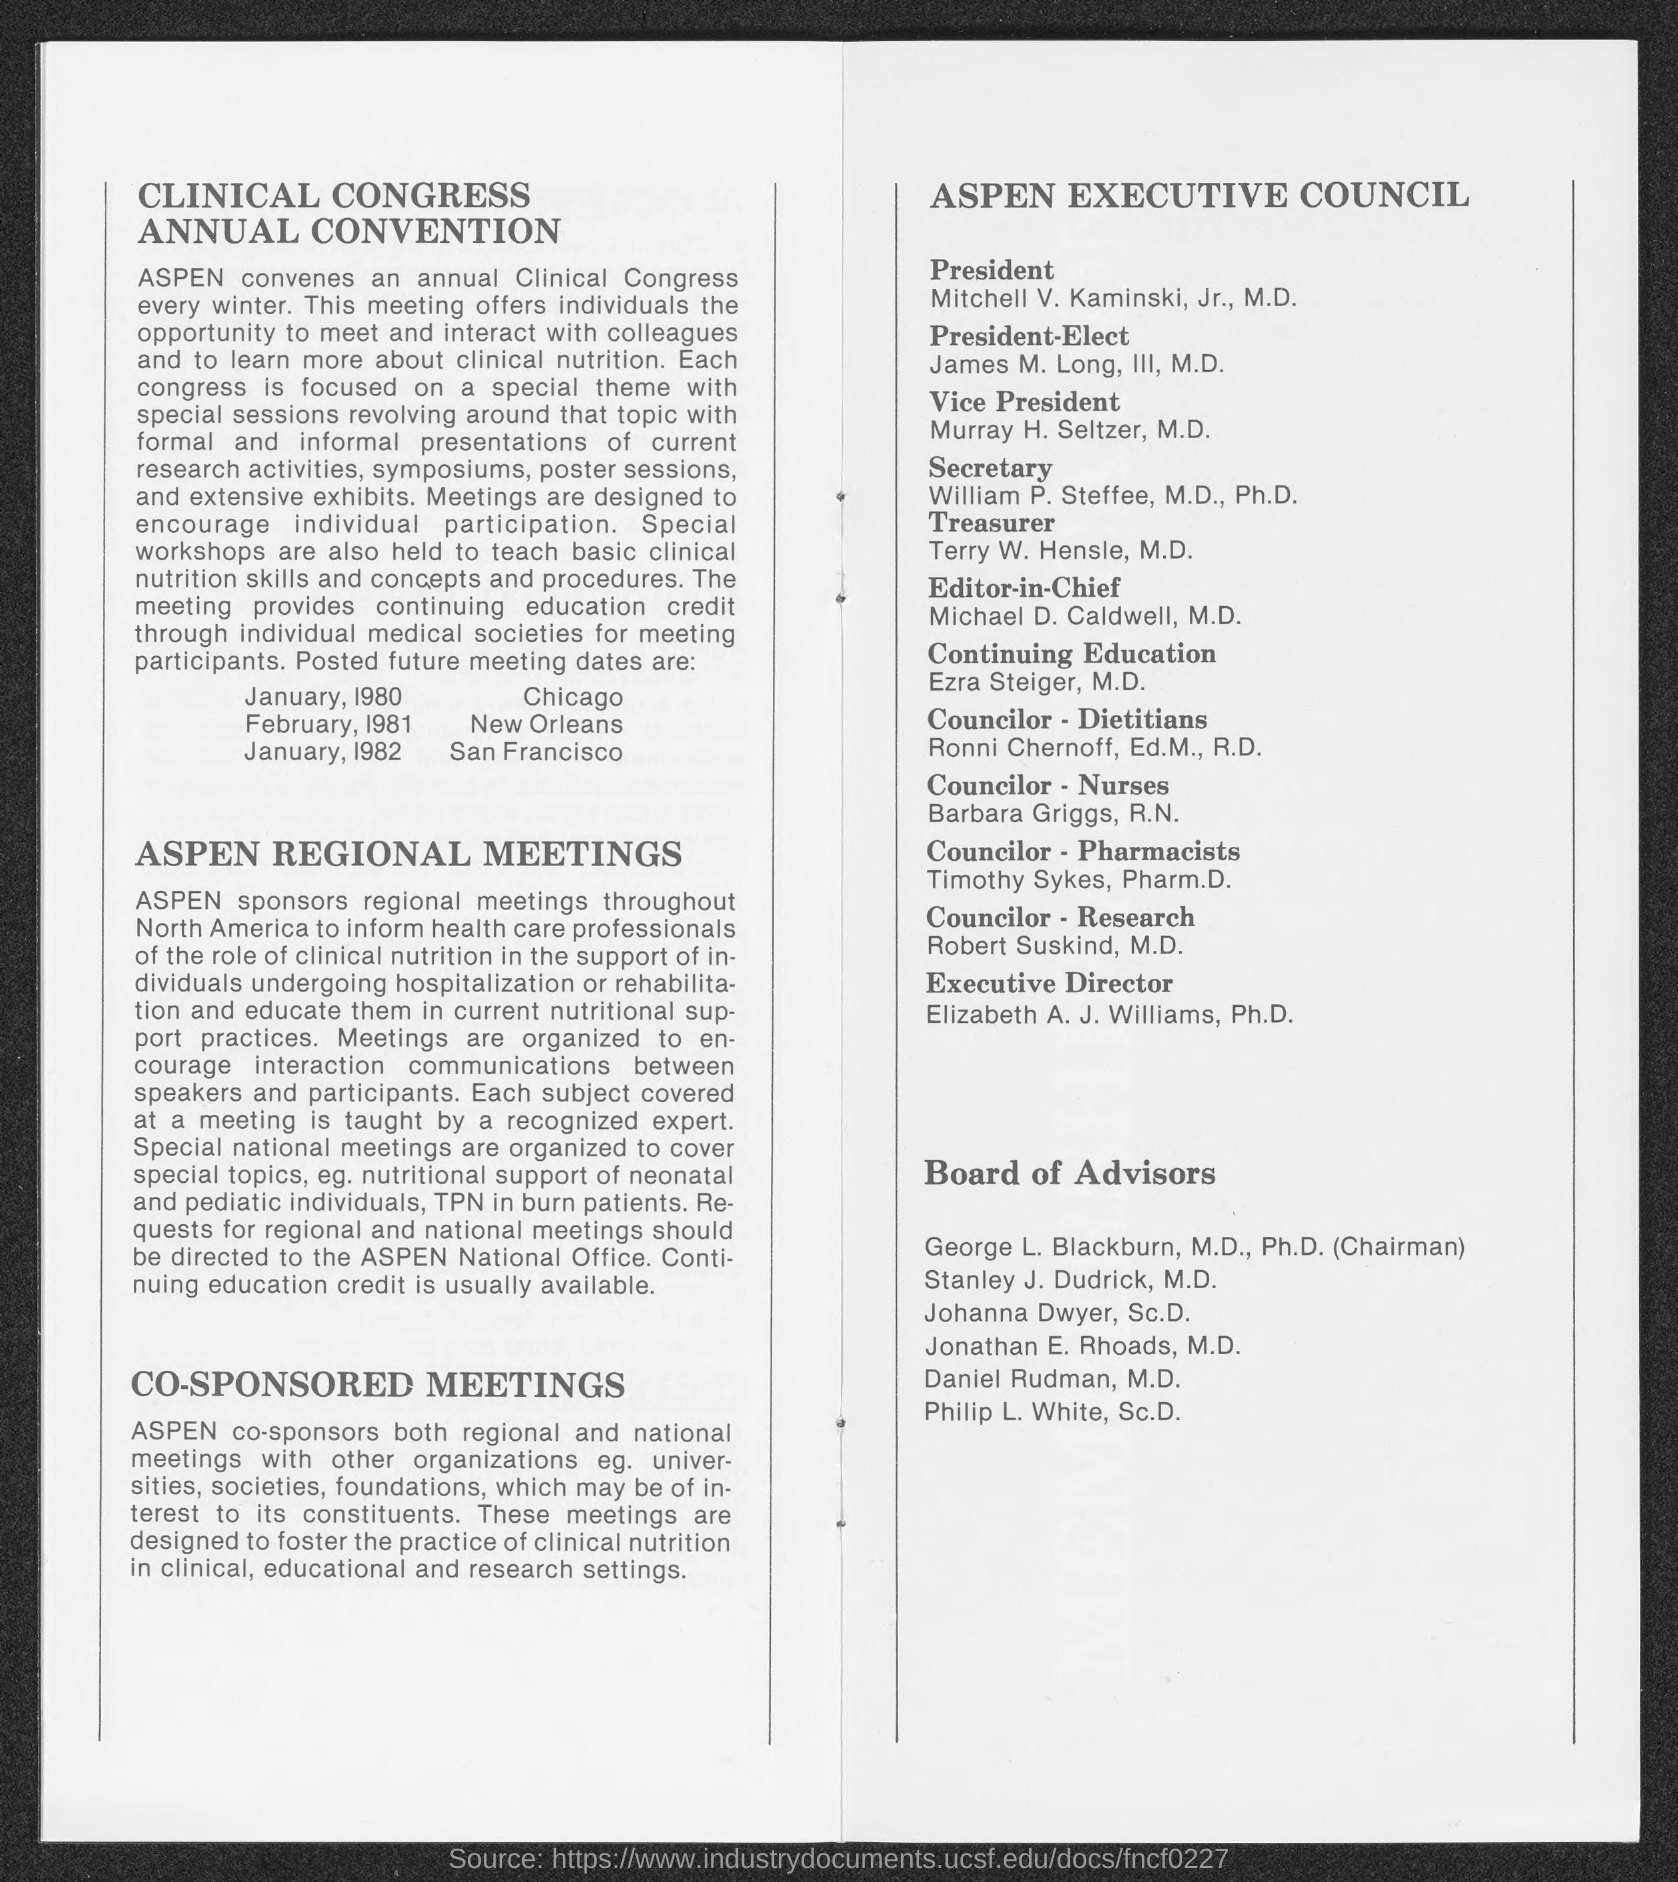Indicate a few pertinent items in this graphic. The ASPEN meeting is scheduled to take place in Chicago in January of 1980. It is known that the ASPEN meeting will be held in San Francisco in January 1982. The ASPEN meeting will be held in New Orleans in February 1981. The ASPEN Executive Council's secretary is William P. Steffee. The President of the ASPEN Executive Council is Mitchell V. Kaminski, Jr., M.D. 